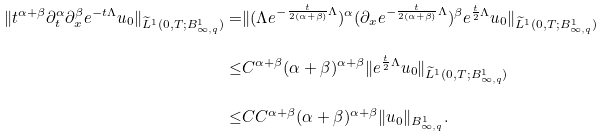<formula> <loc_0><loc_0><loc_500><loc_500>\| t ^ { \alpha + \beta } \partial _ { t } ^ { \alpha } \partial _ { x } ^ { \beta } e ^ { - t \Lambda } u _ { 0 } \| _ { \widetilde { L } ^ { 1 } ( 0 , T ; B ^ { 1 } _ { \infty , q } ) } = & \| ( \Lambda e ^ { - \frac { t } { 2 ( \alpha + \beta ) } \Lambda } ) ^ { \alpha } ( \partial _ { x } e ^ { - \frac { t } { 2 ( \alpha + \beta ) } \Lambda } ) ^ { \beta } e ^ { \frac { t } { 2 } \Lambda } u _ { 0 } \| _ { \widetilde { L } ^ { 1 } ( 0 , T ; B ^ { 1 } _ { \infty , q } ) } \\ \leq & C ^ { \alpha + \beta } ( \alpha + \beta ) ^ { \alpha + \beta } \| e ^ { \frac { t } { 2 } \Lambda } u _ { 0 } \| _ { \widetilde { L } ^ { 1 } ( 0 , T ; B ^ { 1 } _ { \infty , q } ) } \\ \leq & C C ^ { \alpha + \beta } ( \alpha + \beta ) ^ { \alpha + \beta } \| u _ { 0 } \| _ { B ^ { 1 } _ { \infty , q } } .</formula> 